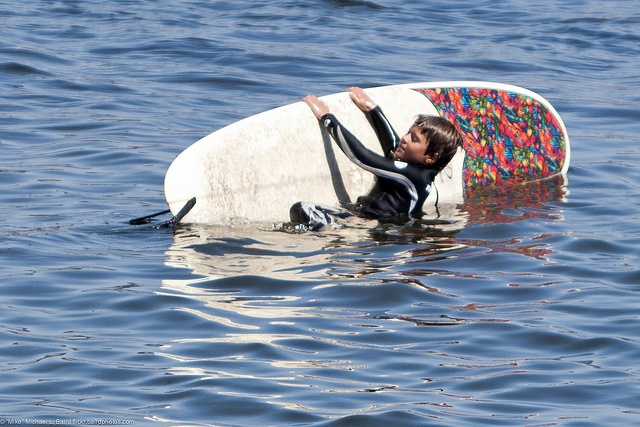Describe the objects in this image and their specific colors. I can see surfboard in darkgray, ivory, gray, and salmon tones and people in darkgray, black, gray, and lightgray tones in this image. 